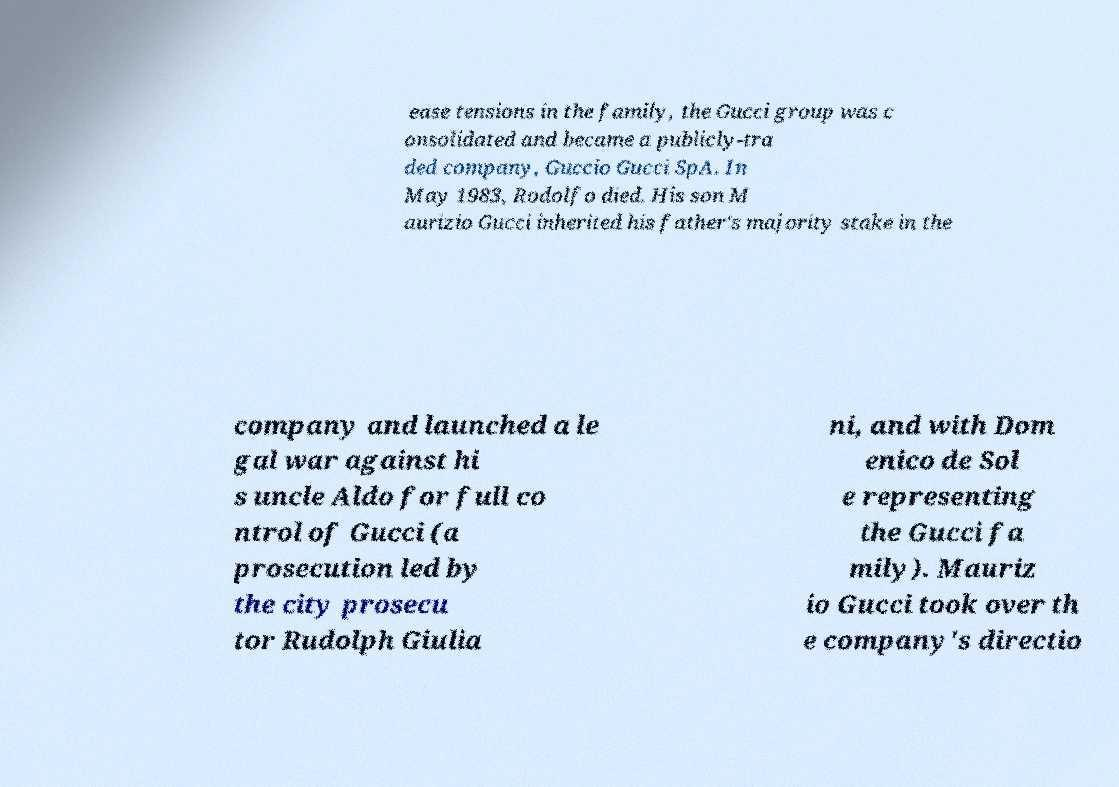Can you accurately transcribe the text from the provided image for me? ease tensions in the family, the Gucci group was c onsolidated and became a publicly-tra ded company, Guccio Gucci SpA. In May 1983, Rodolfo died. His son M aurizio Gucci inherited his father's majority stake in the company and launched a le gal war against hi s uncle Aldo for full co ntrol of Gucci (a prosecution led by the city prosecu tor Rudolph Giulia ni, and with Dom enico de Sol e representing the Gucci fa mily). Mauriz io Gucci took over th e company's directio 